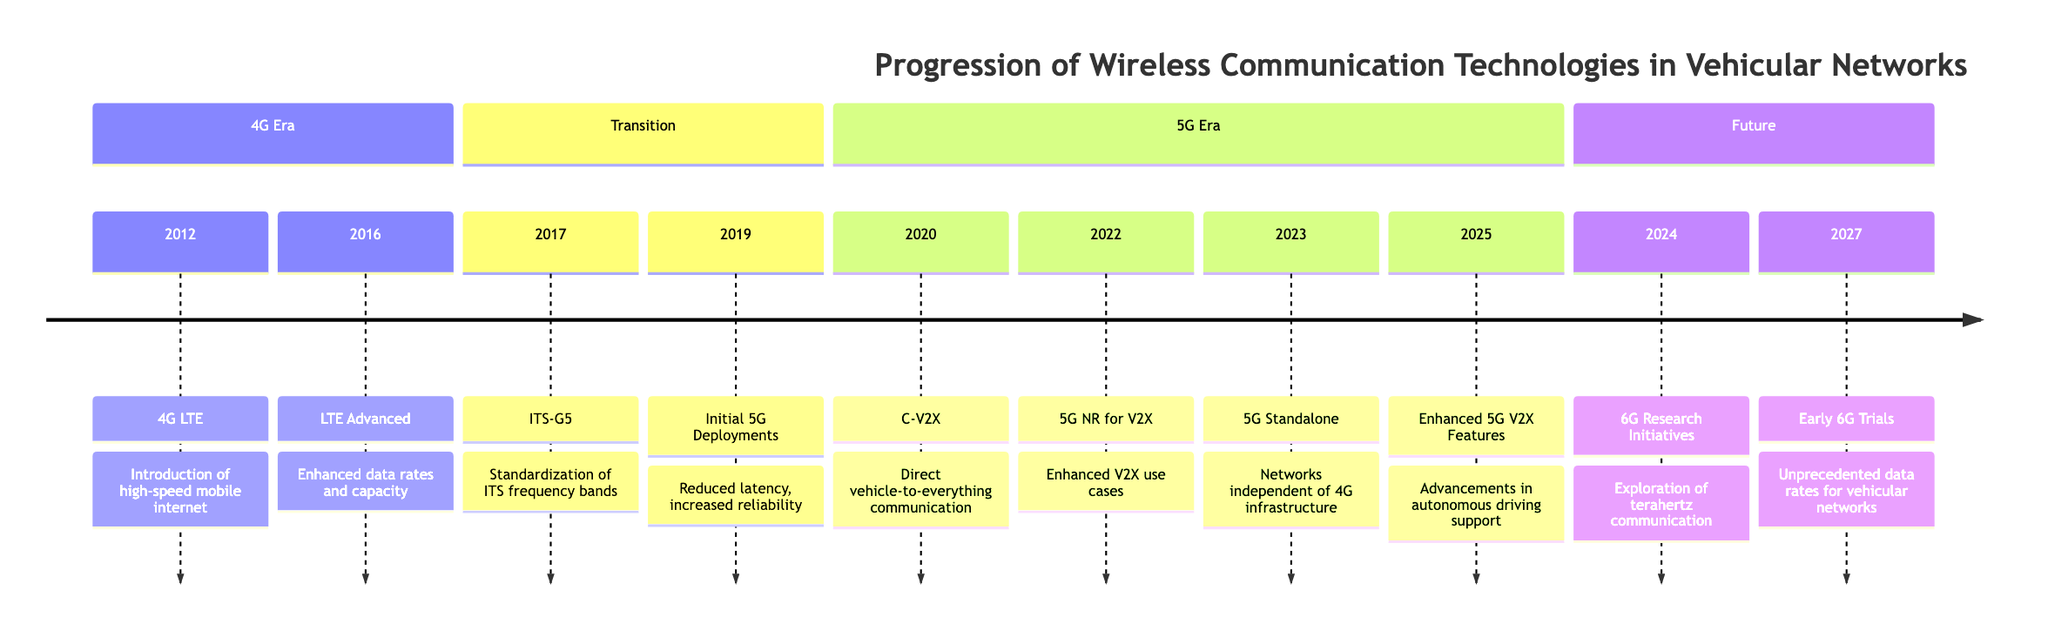What technology was introduced in 2012? The first node in the timeline shows that in 2012, 4G LTE was the technology introduced.
Answer: 4G LTE What year did LTE Advanced get introduced? The timeline indicates that LTE Advanced was introduced in 2016, as shown in the corresponding node.
Answer: 2016 How many technologies are listed in the 5G Era section? By counting the nodes under the 5G Era section (C-V2X, 5G NR for V2X, 5G Standalone, Enhanced 5G V2X Features), there are four technologies listed.
Answer: 4 What impact did Initial 5G Deployments have in 2019? The node for Initial 5G Deployments in 2019 indicates that they significantly reduced latency and increased reliability for V2X communications.
Answer: Reduced latency, increased reliability Which year follows the introduction of ITS-G5? Following the ITS-G5 introduction in 2017, the timeline shows that Initial 5G Deployments occurred in 2019, indicating the year that follows is 2019.
Answer: 2019 What is the expected impact of 6G Research Initiatives in 2024? The 6G Research Initiatives node states that it explores terahertz communication and AI-driven networks for ultra-low latency V2X services, indicating its expected impact centers around communication advancements.
Answer: Exploration of terahertz communication Which two technologies were deployed in 2022? The node for 2022 shows that 5G NR for V2X was implemented, and it follows the C-V2X deployment that happened beforehand, confirming these as the notable technologies for that year.
Answer: 5G NR for V2X and C-V2X In which region have 2023 deployments expanded significantly? The node for 2023 indicates that the expansion occurred in technology hubs like Silicon Valley and smart city projects in Dubai, specifying these regions for 5G Standalone deployment.
Answer: Silicon Valley and Dubai Which technology was first to enable V2X in 2012? The first relevant node in the timeline discusses 4G LTE as the technology that introduced basic V2X communication in 2012, thereby identifying it as the first to enable V2X.
Answer: 4G LTE 